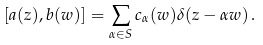<formula> <loc_0><loc_0><loc_500><loc_500>[ a ( z ) , b ( w ) ] = \sum _ { \alpha \in S } c _ { \alpha } ( w ) \delta ( z - \alpha w ) \, .</formula> 